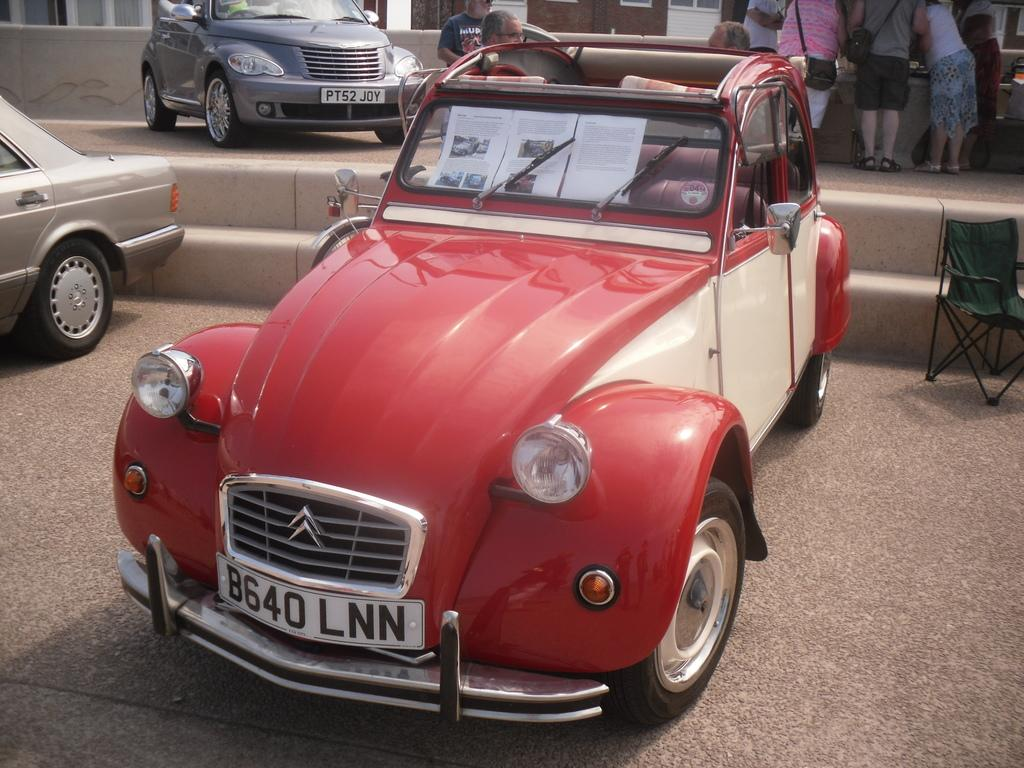How many cars are visible in the image? There are three cars in the image. What is happening with the people behind the first car? There are people standing behind the first car. Can you describe any additional objects or features in the image? There is an empty chair on the right side of the image. How many fingers are visible on the people standing behind the first car? The number of fingers visible on the people standing behind the first car cannot be determined from the image. Are there any spiders crawling on the cars in the image? There are no spiders visible in the image. 